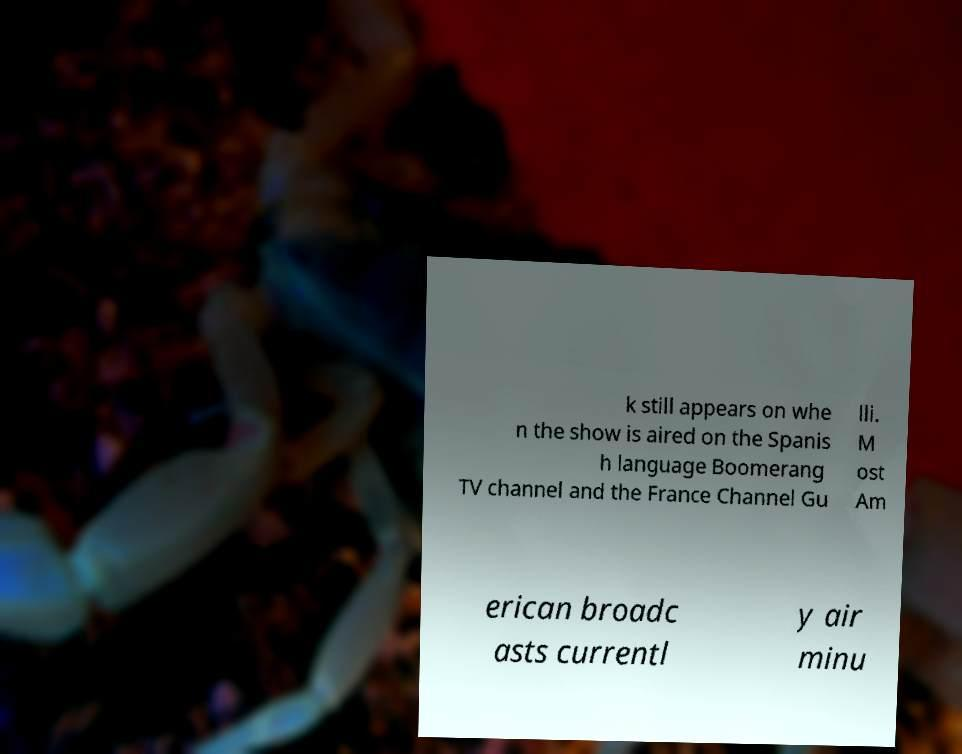For documentation purposes, I need the text within this image transcribed. Could you provide that? k still appears on whe n the show is aired on the Spanis h language Boomerang TV channel and the France Channel Gu lli. M ost Am erican broadc asts currentl y air minu 